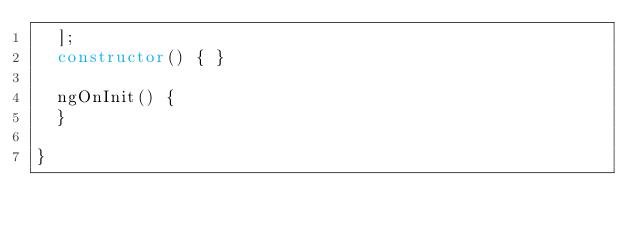Convert code to text. <code><loc_0><loc_0><loc_500><loc_500><_TypeScript_>  ];
  constructor() { }

  ngOnInit() {
  }

}
</code> 